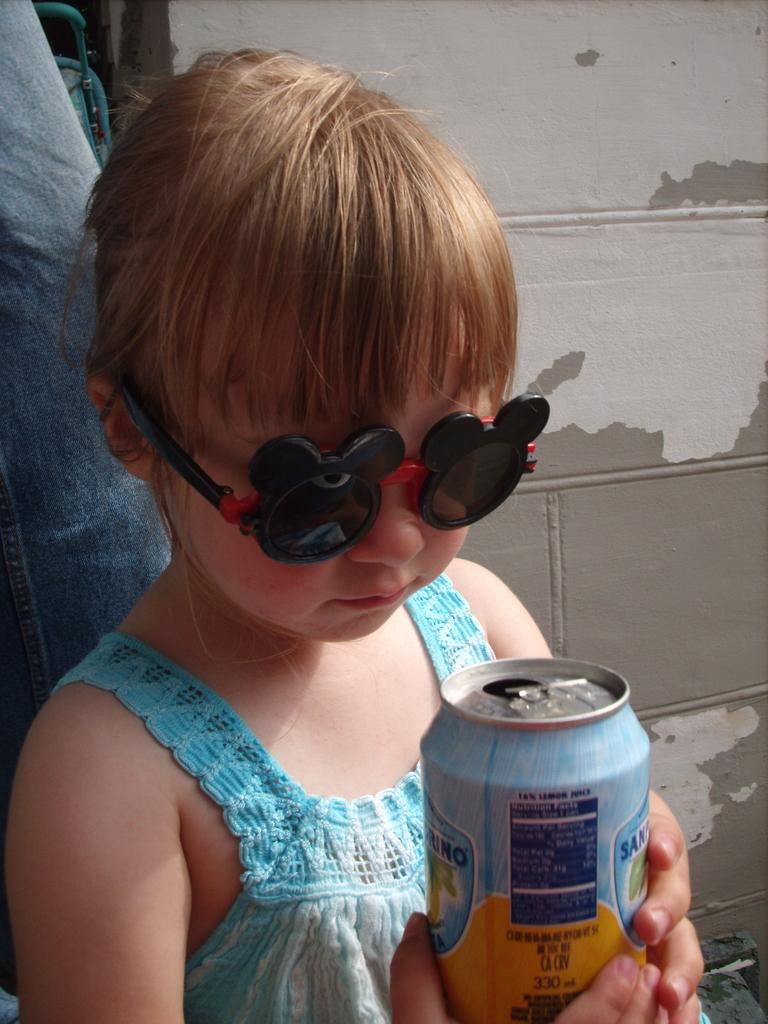What is the main subject in the foreground of the image? There is a kid in the foreground of the image. What is the kid holding in the image? The kid is holding a tin. Can you describe the kid's appearance? The kid is wearing spectacles. What can be seen in the background of the image? There is a leg of a person and a wall in the background of the image. What type of news can be heard coming from the tin in the image? There is no indication in the image that the tin contains news or any sound-producing device. 